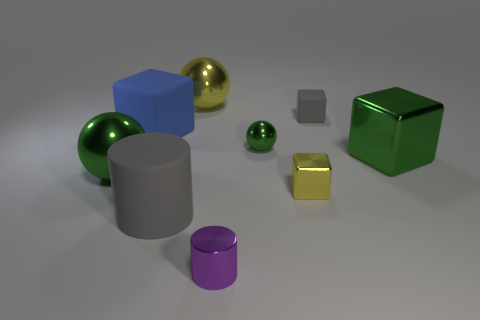Is the shape of the big gray matte object the same as the metallic thing to the left of the yellow metallic ball?
Provide a succinct answer. No. What number of other objects are the same shape as the big blue object?
Ensure brevity in your answer.  3. What color is the thing that is both to the right of the tiny yellow object and in front of the tiny green metal object?
Offer a terse response. Green. What is the color of the rubber cylinder?
Your answer should be very brief. Gray. Does the large green cube have the same material as the small thing to the right of the small shiny block?
Provide a succinct answer. No. There is a tiny yellow thing that is the same material as the yellow ball; what shape is it?
Your answer should be very brief. Cube. There is a block that is the same size as the blue thing; what is its color?
Ensure brevity in your answer.  Green. There is a yellow metallic object that is on the left side of the purple shiny object; does it have the same size as the tiny purple cylinder?
Your response must be concise. No. Is the rubber cylinder the same color as the tiny sphere?
Your response must be concise. No. What number of shiny spheres are there?
Provide a succinct answer. 3. 